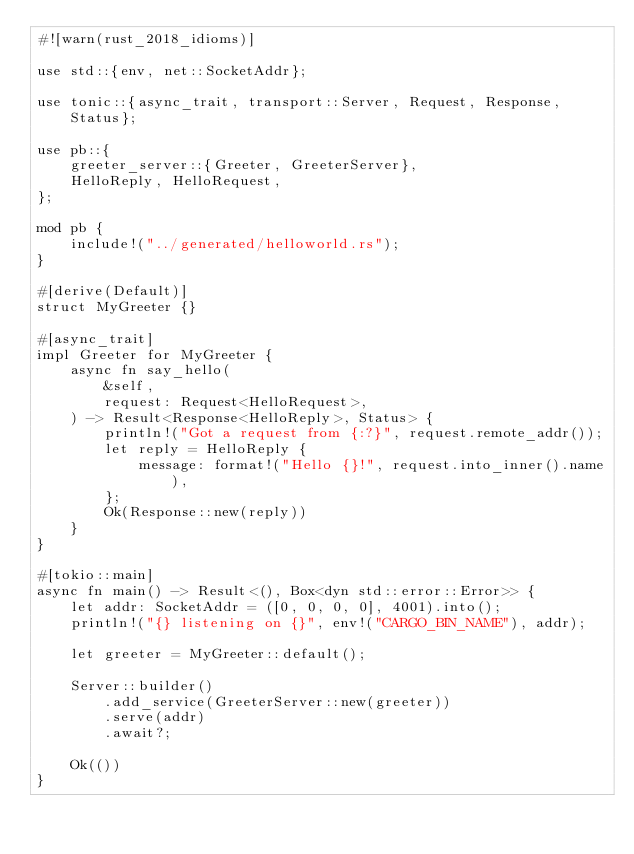Convert code to text. <code><loc_0><loc_0><loc_500><loc_500><_Rust_>#![warn(rust_2018_idioms)]

use std::{env, net::SocketAddr};

use tonic::{async_trait, transport::Server, Request, Response, Status};

use pb::{
    greeter_server::{Greeter, GreeterServer},
    HelloReply, HelloRequest,
};

mod pb {
    include!("../generated/helloworld.rs");
}

#[derive(Default)]
struct MyGreeter {}

#[async_trait]
impl Greeter for MyGreeter {
    async fn say_hello(
        &self,
        request: Request<HelloRequest>,
    ) -> Result<Response<HelloReply>, Status> {
        println!("Got a request from {:?}", request.remote_addr());
        let reply = HelloReply {
            message: format!("Hello {}!", request.into_inner().name),
        };
        Ok(Response::new(reply))
    }
}

#[tokio::main]
async fn main() -> Result<(), Box<dyn std::error::Error>> {
    let addr: SocketAddr = ([0, 0, 0, 0], 4001).into();
    println!("{} listening on {}", env!("CARGO_BIN_NAME"), addr);

    let greeter = MyGreeter::default();

    Server::builder()
        .add_service(GreeterServer::new(greeter))
        .serve(addr)
        .await?;

    Ok(())
}
</code> 